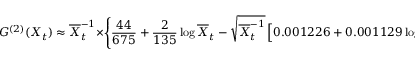<formula> <loc_0><loc_0><loc_500><loc_500>G ^ { ( 2 ) } ( X _ { t } ) \approx { \overline { X } _ { t } ^ { - 1 } } \times \left \{ { \frac { 4 4 } { 6 7 5 } } + { \frac { 2 } { 1 3 5 } } \log \overline { X } _ { t } - \sqrt { \overline { X } _ { t } ^ { - 1 } } \left [ 0 . 0 0 1 2 2 6 + 0 . 0 0 1 1 2 9 \log \overline { X } _ { t } \right ] \right \} .</formula> 